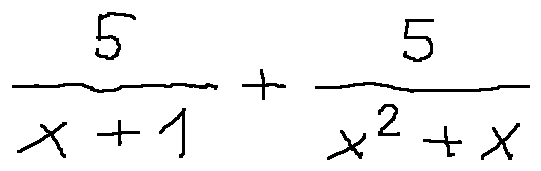Convert formula to latex. <formula><loc_0><loc_0><loc_500><loc_500>\frac { 5 } { x + 1 } + \frac { 5 } { x ^ { 2 } + x }</formula> 